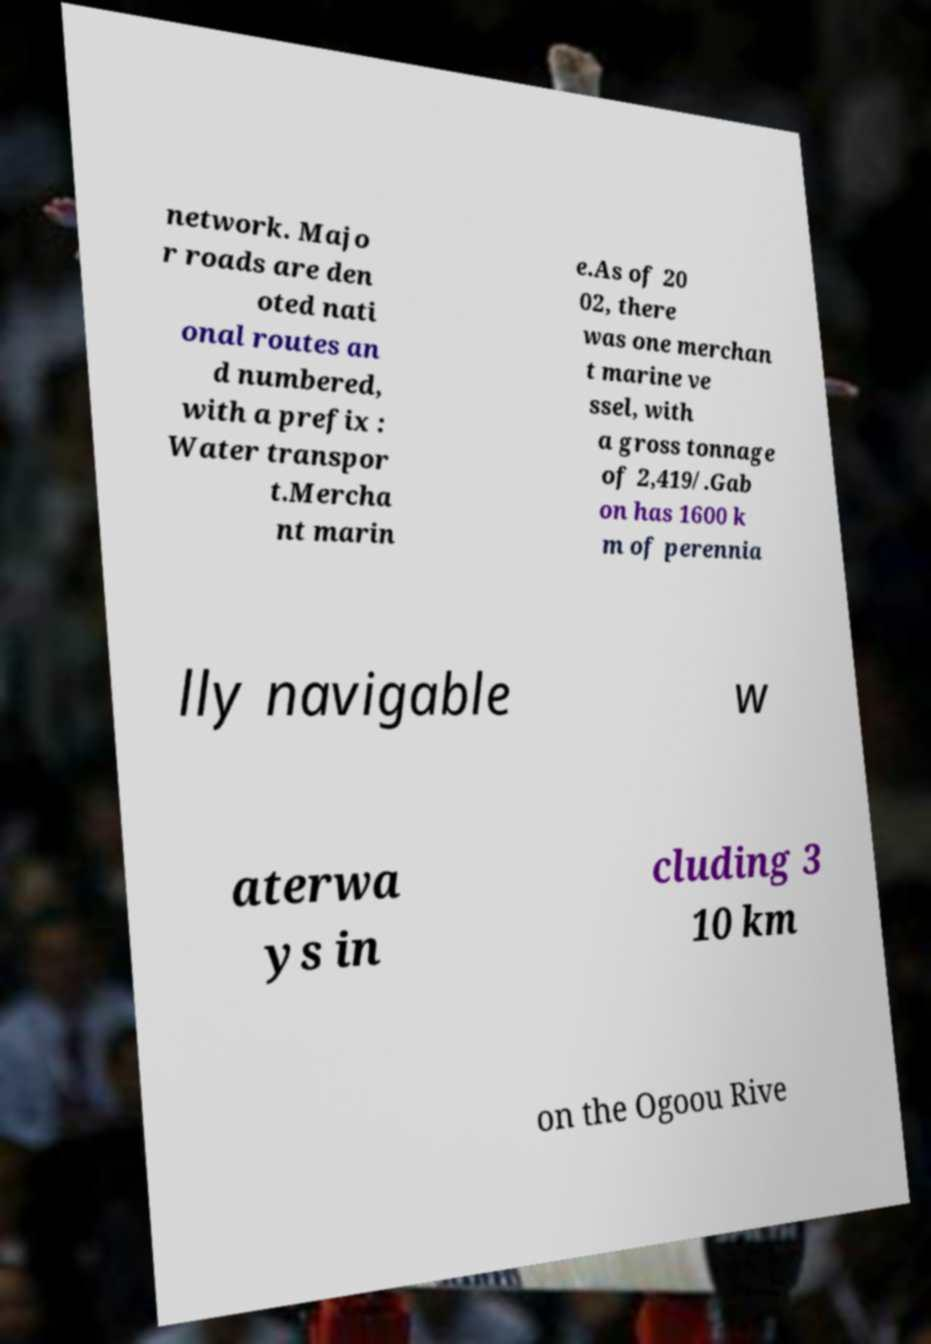Please read and relay the text visible in this image. What does it say? network. Majo r roads are den oted nati onal routes an d numbered, with a prefix : Water transpor t.Mercha nt marin e.As of 20 02, there was one merchan t marine ve ssel, with a gross tonnage of 2,419/.Gab on has 1600 k m of perennia lly navigable w aterwa ys in cluding 3 10 km on the Ogoou Rive 